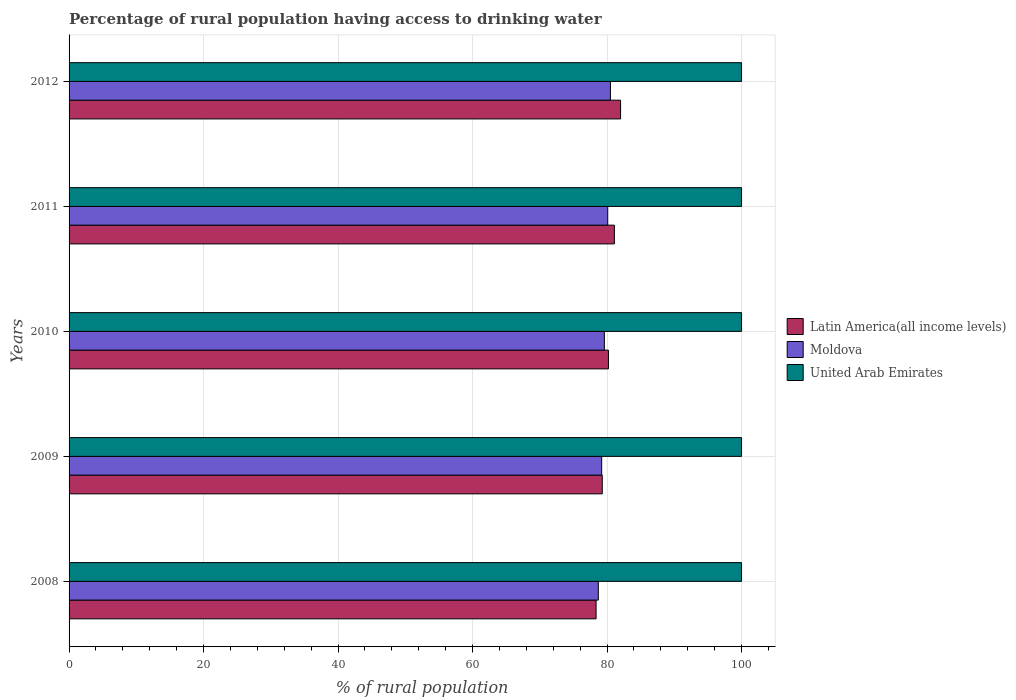How many different coloured bars are there?
Make the answer very short. 3. How many groups of bars are there?
Offer a very short reply. 5. What is the label of the 4th group of bars from the top?
Offer a terse response. 2009. In how many cases, is the number of bars for a given year not equal to the number of legend labels?
Your answer should be very brief. 0. What is the percentage of rural population having access to drinking water in Latin America(all income levels) in 2012?
Keep it short and to the point. 82.01. Across all years, what is the maximum percentage of rural population having access to drinking water in Latin America(all income levels)?
Make the answer very short. 82.01. Across all years, what is the minimum percentage of rural population having access to drinking water in Moldova?
Give a very brief answer. 78.7. What is the total percentage of rural population having access to drinking water in United Arab Emirates in the graph?
Keep it short and to the point. 500. What is the difference between the percentage of rural population having access to drinking water in Latin America(all income levels) in 2009 and the percentage of rural population having access to drinking water in Moldova in 2011?
Keep it short and to the point. -0.81. In the year 2012, what is the difference between the percentage of rural population having access to drinking water in Moldova and percentage of rural population having access to drinking water in Latin America(all income levels)?
Give a very brief answer. -1.51. What is the ratio of the percentage of rural population having access to drinking water in United Arab Emirates in 2009 to that in 2011?
Your answer should be compact. 1. Is the difference between the percentage of rural population having access to drinking water in Moldova in 2011 and 2012 greater than the difference between the percentage of rural population having access to drinking water in Latin America(all income levels) in 2011 and 2012?
Offer a terse response. Yes. What is the difference between the highest and the lowest percentage of rural population having access to drinking water in Moldova?
Ensure brevity in your answer.  1.8. In how many years, is the percentage of rural population having access to drinking water in Latin America(all income levels) greater than the average percentage of rural population having access to drinking water in Latin America(all income levels) taken over all years?
Provide a succinct answer. 3. Is the sum of the percentage of rural population having access to drinking water in Moldova in 2009 and 2011 greater than the maximum percentage of rural population having access to drinking water in Latin America(all income levels) across all years?
Offer a terse response. Yes. What does the 3rd bar from the top in 2010 represents?
Give a very brief answer. Latin America(all income levels). What does the 3rd bar from the bottom in 2010 represents?
Offer a terse response. United Arab Emirates. How many bars are there?
Provide a short and direct response. 15. How many years are there in the graph?
Your answer should be compact. 5. Does the graph contain any zero values?
Your answer should be very brief. No. Does the graph contain grids?
Ensure brevity in your answer.  Yes. Where does the legend appear in the graph?
Ensure brevity in your answer.  Center right. How many legend labels are there?
Keep it short and to the point. 3. How are the legend labels stacked?
Make the answer very short. Vertical. What is the title of the graph?
Your answer should be compact. Percentage of rural population having access to drinking water. What is the label or title of the X-axis?
Make the answer very short. % of rural population. What is the % of rural population of Latin America(all income levels) in 2008?
Keep it short and to the point. 78.37. What is the % of rural population of Moldova in 2008?
Provide a succinct answer. 78.7. What is the % of rural population of United Arab Emirates in 2008?
Provide a short and direct response. 100. What is the % of rural population of Latin America(all income levels) in 2009?
Ensure brevity in your answer.  79.29. What is the % of rural population in Moldova in 2009?
Provide a succinct answer. 79.2. What is the % of rural population in United Arab Emirates in 2009?
Your response must be concise. 100. What is the % of rural population of Latin America(all income levels) in 2010?
Offer a very short reply. 80.21. What is the % of rural population of Moldova in 2010?
Offer a terse response. 79.6. What is the % of rural population in United Arab Emirates in 2010?
Your answer should be very brief. 100. What is the % of rural population of Latin America(all income levels) in 2011?
Offer a terse response. 81.09. What is the % of rural population of Moldova in 2011?
Your answer should be compact. 80.1. What is the % of rural population of Latin America(all income levels) in 2012?
Provide a succinct answer. 82.01. What is the % of rural population in Moldova in 2012?
Offer a very short reply. 80.5. What is the % of rural population in United Arab Emirates in 2012?
Offer a very short reply. 100. Across all years, what is the maximum % of rural population of Latin America(all income levels)?
Provide a succinct answer. 82.01. Across all years, what is the maximum % of rural population in Moldova?
Provide a succinct answer. 80.5. Across all years, what is the minimum % of rural population of Latin America(all income levels)?
Your answer should be compact. 78.37. Across all years, what is the minimum % of rural population of Moldova?
Offer a terse response. 78.7. What is the total % of rural population in Latin America(all income levels) in the graph?
Your response must be concise. 400.96. What is the total % of rural population of Moldova in the graph?
Offer a very short reply. 398.1. What is the total % of rural population in United Arab Emirates in the graph?
Give a very brief answer. 500. What is the difference between the % of rural population of Latin America(all income levels) in 2008 and that in 2009?
Offer a terse response. -0.92. What is the difference between the % of rural population in United Arab Emirates in 2008 and that in 2009?
Your answer should be compact. 0. What is the difference between the % of rural population of Latin America(all income levels) in 2008 and that in 2010?
Keep it short and to the point. -1.84. What is the difference between the % of rural population in Moldova in 2008 and that in 2010?
Offer a terse response. -0.9. What is the difference between the % of rural population in Latin America(all income levels) in 2008 and that in 2011?
Your answer should be very brief. -2.72. What is the difference between the % of rural population of Moldova in 2008 and that in 2011?
Offer a very short reply. -1.4. What is the difference between the % of rural population of Latin America(all income levels) in 2008 and that in 2012?
Offer a very short reply. -3.64. What is the difference between the % of rural population in Moldova in 2008 and that in 2012?
Provide a succinct answer. -1.8. What is the difference between the % of rural population in United Arab Emirates in 2008 and that in 2012?
Your answer should be very brief. 0. What is the difference between the % of rural population in Latin America(all income levels) in 2009 and that in 2010?
Offer a terse response. -0.92. What is the difference between the % of rural population in United Arab Emirates in 2009 and that in 2010?
Offer a terse response. 0. What is the difference between the % of rural population in Latin America(all income levels) in 2009 and that in 2011?
Your answer should be compact. -1.8. What is the difference between the % of rural population of Latin America(all income levels) in 2009 and that in 2012?
Your response must be concise. -2.72. What is the difference between the % of rural population in United Arab Emirates in 2009 and that in 2012?
Your answer should be compact. 0. What is the difference between the % of rural population of Latin America(all income levels) in 2010 and that in 2011?
Make the answer very short. -0.88. What is the difference between the % of rural population of Moldova in 2010 and that in 2011?
Offer a terse response. -0.5. What is the difference between the % of rural population in United Arab Emirates in 2010 and that in 2011?
Provide a succinct answer. 0. What is the difference between the % of rural population in Latin America(all income levels) in 2010 and that in 2012?
Make the answer very short. -1.8. What is the difference between the % of rural population of Moldova in 2010 and that in 2012?
Ensure brevity in your answer.  -0.9. What is the difference between the % of rural population in United Arab Emirates in 2010 and that in 2012?
Offer a very short reply. 0. What is the difference between the % of rural population in Latin America(all income levels) in 2011 and that in 2012?
Your response must be concise. -0.92. What is the difference between the % of rural population of United Arab Emirates in 2011 and that in 2012?
Your response must be concise. 0. What is the difference between the % of rural population in Latin America(all income levels) in 2008 and the % of rural population in Moldova in 2009?
Offer a terse response. -0.83. What is the difference between the % of rural population in Latin America(all income levels) in 2008 and the % of rural population in United Arab Emirates in 2009?
Make the answer very short. -21.63. What is the difference between the % of rural population in Moldova in 2008 and the % of rural population in United Arab Emirates in 2009?
Offer a very short reply. -21.3. What is the difference between the % of rural population of Latin America(all income levels) in 2008 and the % of rural population of Moldova in 2010?
Keep it short and to the point. -1.23. What is the difference between the % of rural population in Latin America(all income levels) in 2008 and the % of rural population in United Arab Emirates in 2010?
Offer a very short reply. -21.63. What is the difference between the % of rural population in Moldova in 2008 and the % of rural population in United Arab Emirates in 2010?
Your response must be concise. -21.3. What is the difference between the % of rural population in Latin America(all income levels) in 2008 and the % of rural population in Moldova in 2011?
Give a very brief answer. -1.73. What is the difference between the % of rural population in Latin America(all income levels) in 2008 and the % of rural population in United Arab Emirates in 2011?
Offer a terse response. -21.63. What is the difference between the % of rural population of Moldova in 2008 and the % of rural population of United Arab Emirates in 2011?
Your response must be concise. -21.3. What is the difference between the % of rural population in Latin America(all income levels) in 2008 and the % of rural population in Moldova in 2012?
Keep it short and to the point. -2.13. What is the difference between the % of rural population of Latin America(all income levels) in 2008 and the % of rural population of United Arab Emirates in 2012?
Your answer should be compact. -21.63. What is the difference between the % of rural population in Moldova in 2008 and the % of rural population in United Arab Emirates in 2012?
Keep it short and to the point. -21.3. What is the difference between the % of rural population of Latin America(all income levels) in 2009 and the % of rural population of Moldova in 2010?
Provide a short and direct response. -0.31. What is the difference between the % of rural population in Latin America(all income levels) in 2009 and the % of rural population in United Arab Emirates in 2010?
Keep it short and to the point. -20.71. What is the difference between the % of rural population in Moldova in 2009 and the % of rural population in United Arab Emirates in 2010?
Your answer should be very brief. -20.8. What is the difference between the % of rural population in Latin America(all income levels) in 2009 and the % of rural population in Moldova in 2011?
Offer a terse response. -0.81. What is the difference between the % of rural population in Latin America(all income levels) in 2009 and the % of rural population in United Arab Emirates in 2011?
Keep it short and to the point. -20.71. What is the difference between the % of rural population of Moldova in 2009 and the % of rural population of United Arab Emirates in 2011?
Your response must be concise. -20.8. What is the difference between the % of rural population of Latin America(all income levels) in 2009 and the % of rural population of Moldova in 2012?
Give a very brief answer. -1.21. What is the difference between the % of rural population of Latin America(all income levels) in 2009 and the % of rural population of United Arab Emirates in 2012?
Provide a succinct answer. -20.71. What is the difference between the % of rural population in Moldova in 2009 and the % of rural population in United Arab Emirates in 2012?
Give a very brief answer. -20.8. What is the difference between the % of rural population in Latin America(all income levels) in 2010 and the % of rural population in Moldova in 2011?
Your answer should be very brief. 0.11. What is the difference between the % of rural population in Latin America(all income levels) in 2010 and the % of rural population in United Arab Emirates in 2011?
Provide a succinct answer. -19.79. What is the difference between the % of rural population in Moldova in 2010 and the % of rural population in United Arab Emirates in 2011?
Make the answer very short. -20.4. What is the difference between the % of rural population in Latin America(all income levels) in 2010 and the % of rural population in Moldova in 2012?
Your answer should be compact. -0.29. What is the difference between the % of rural population of Latin America(all income levels) in 2010 and the % of rural population of United Arab Emirates in 2012?
Provide a short and direct response. -19.79. What is the difference between the % of rural population in Moldova in 2010 and the % of rural population in United Arab Emirates in 2012?
Offer a very short reply. -20.4. What is the difference between the % of rural population of Latin America(all income levels) in 2011 and the % of rural population of Moldova in 2012?
Keep it short and to the point. 0.59. What is the difference between the % of rural population in Latin America(all income levels) in 2011 and the % of rural population in United Arab Emirates in 2012?
Your answer should be compact. -18.91. What is the difference between the % of rural population in Moldova in 2011 and the % of rural population in United Arab Emirates in 2012?
Make the answer very short. -19.9. What is the average % of rural population of Latin America(all income levels) per year?
Offer a very short reply. 80.19. What is the average % of rural population in Moldova per year?
Ensure brevity in your answer.  79.62. In the year 2008, what is the difference between the % of rural population of Latin America(all income levels) and % of rural population of Moldova?
Give a very brief answer. -0.33. In the year 2008, what is the difference between the % of rural population of Latin America(all income levels) and % of rural population of United Arab Emirates?
Keep it short and to the point. -21.63. In the year 2008, what is the difference between the % of rural population of Moldova and % of rural population of United Arab Emirates?
Make the answer very short. -21.3. In the year 2009, what is the difference between the % of rural population in Latin America(all income levels) and % of rural population in Moldova?
Offer a terse response. 0.09. In the year 2009, what is the difference between the % of rural population in Latin America(all income levels) and % of rural population in United Arab Emirates?
Ensure brevity in your answer.  -20.71. In the year 2009, what is the difference between the % of rural population of Moldova and % of rural population of United Arab Emirates?
Give a very brief answer. -20.8. In the year 2010, what is the difference between the % of rural population of Latin America(all income levels) and % of rural population of Moldova?
Ensure brevity in your answer.  0.61. In the year 2010, what is the difference between the % of rural population in Latin America(all income levels) and % of rural population in United Arab Emirates?
Make the answer very short. -19.79. In the year 2010, what is the difference between the % of rural population in Moldova and % of rural population in United Arab Emirates?
Provide a succinct answer. -20.4. In the year 2011, what is the difference between the % of rural population in Latin America(all income levels) and % of rural population in Moldova?
Your answer should be very brief. 0.99. In the year 2011, what is the difference between the % of rural population of Latin America(all income levels) and % of rural population of United Arab Emirates?
Offer a very short reply. -18.91. In the year 2011, what is the difference between the % of rural population of Moldova and % of rural population of United Arab Emirates?
Make the answer very short. -19.9. In the year 2012, what is the difference between the % of rural population in Latin America(all income levels) and % of rural population in Moldova?
Offer a terse response. 1.51. In the year 2012, what is the difference between the % of rural population in Latin America(all income levels) and % of rural population in United Arab Emirates?
Keep it short and to the point. -17.99. In the year 2012, what is the difference between the % of rural population in Moldova and % of rural population in United Arab Emirates?
Ensure brevity in your answer.  -19.5. What is the ratio of the % of rural population of Latin America(all income levels) in 2008 to that in 2009?
Provide a short and direct response. 0.99. What is the ratio of the % of rural population in Moldova in 2008 to that in 2009?
Provide a short and direct response. 0.99. What is the ratio of the % of rural population of United Arab Emirates in 2008 to that in 2009?
Provide a succinct answer. 1. What is the ratio of the % of rural population of Latin America(all income levels) in 2008 to that in 2010?
Offer a terse response. 0.98. What is the ratio of the % of rural population of Moldova in 2008 to that in 2010?
Your answer should be very brief. 0.99. What is the ratio of the % of rural population in Latin America(all income levels) in 2008 to that in 2011?
Ensure brevity in your answer.  0.97. What is the ratio of the % of rural population in Moldova in 2008 to that in 2011?
Your answer should be compact. 0.98. What is the ratio of the % of rural population in Latin America(all income levels) in 2008 to that in 2012?
Provide a short and direct response. 0.96. What is the ratio of the % of rural population of Moldova in 2008 to that in 2012?
Offer a terse response. 0.98. What is the ratio of the % of rural population in United Arab Emirates in 2008 to that in 2012?
Provide a short and direct response. 1. What is the ratio of the % of rural population of Latin America(all income levels) in 2009 to that in 2010?
Your answer should be compact. 0.99. What is the ratio of the % of rural population in Moldova in 2009 to that in 2010?
Make the answer very short. 0.99. What is the ratio of the % of rural population in Latin America(all income levels) in 2009 to that in 2011?
Offer a terse response. 0.98. What is the ratio of the % of rural population in United Arab Emirates in 2009 to that in 2011?
Keep it short and to the point. 1. What is the ratio of the % of rural population in Latin America(all income levels) in 2009 to that in 2012?
Offer a terse response. 0.97. What is the ratio of the % of rural population in Moldova in 2009 to that in 2012?
Give a very brief answer. 0.98. What is the ratio of the % of rural population of United Arab Emirates in 2009 to that in 2012?
Keep it short and to the point. 1. What is the ratio of the % of rural population in Latin America(all income levels) in 2010 to that in 2011?
Keep it short and to the point. 0.99. What is the ratio of the % of rural population in United Arab Emirates in 2010 to that in 2011?
Give a very brief answer. 1. What is the ratio of the % of rural population of Latin America(all income levels) in 2010 to that in 2012?
Give a very brief answer. 0.98. What is the ratio of the % of rural population in United Arab Emirates in 2010 to that in 2012?
Your answer should be compact. 1. What is the ratio of the % of rural population of Latin America(all income levels) in 2011 to that in 2012?
Keep it short and to the point. 0.99. What is the difference between the highest and the second highest % of rural population of Latin America(all income levels)?
Provide a succinct answer. 0.92. What is the difference between the highest and the second highest % of rural population in United Arab Emirates?
Keep it short and to the point. 0. What is the difference between the highest and the lowest % of rural population of Latin America(all income levels)?
Offer a very short reply. 3.64. What is the difference between the highest and the lowest % of rural population in United Arab Emirates?
Keep it short and to the point. 0. 